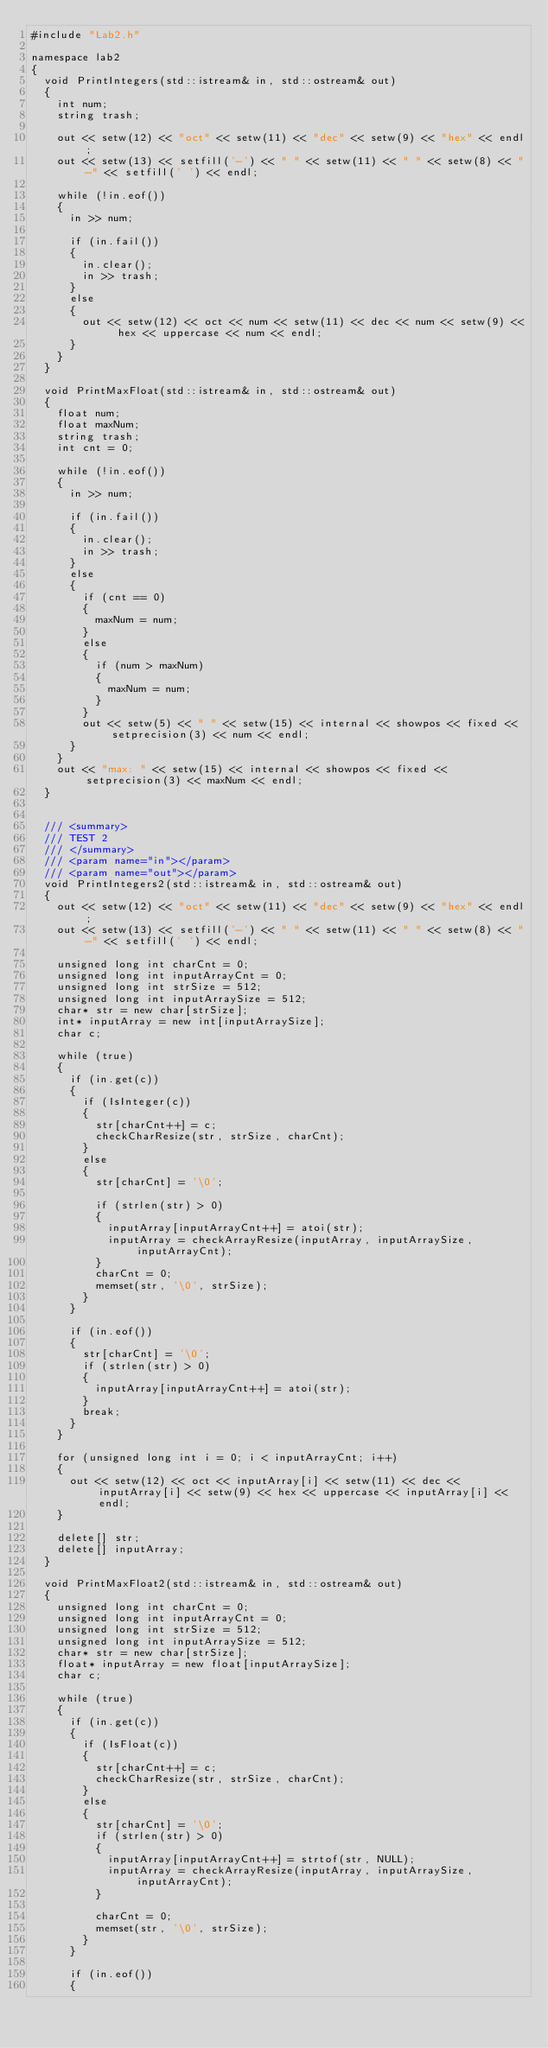Convert code to text. <code><loc_0><loc_0><loc_500><loc_500><_C++_>#include "Lab2.h"

namespace lab2
{
	void PrintIntegers(std::istream& in, std::ostream& out)
	{
		int num;
		string trash;

		out << setw(12) << "oct" << setw(11) << "dec" << setw(9) << "hex" << endl;
		out << setw(13) << setfill('-') << " " << setw(11) << " " << setw(8) << "-" << setfill(' ') << endl;

		while (!in.eof())
		{
			in >> num;

			if (in.fail())
			{
				in.clear();
				in >> trash;
			}
			else
			{
				out << setw(12) << oct << num << setw(11) << dec << num << setw(9) << hex << uppercase << num << endl;
			}
		}
	}

	void PrintMaxFloat(std::istream& in, std::ostream& out)
	{
		float num;
		float maxNum;
		string trash;
		int cnt = 0;

		while (!in.eof())
		{
			in >> num;

			if (in.fail())
			{
				in.clear();
				in >> trash;
			}
			else
			{
				if (cnt == 0)
				{
					maxNum = num;
				}
				else
				{
					if (num > maxNum)
					{
						maxNum = num;
					}
				}
				out << setw(5) << " " << setw(15) << internal << showpos << fixed << setprecision(3) << num << endl;
			}
		}
		out << "max: " << setw(15) << internal << showpos << fixed << setprecision(3) << maxNum << endl;
	}


	/// <summary>
	/// TEST 2
	/// </summary>
	/// <param name="in"></param>
	/// <param name="out"></param>
	void PrintIntegers2(std::istream& in, std::ostream& out)
	{
		out << setw(12) << "oct" << setw(11) << "dec" << setw(9) << "hex" << endl;
		out << setw(13) << setfill('-') << " " << setw(11) << " " << setw(8) << "-" << setfill(' ') << endl;

		unsigned long int charCnt = 0;
		unsigned long int inputArrayCnt = 0;
		unsigned long int strSize = 512;
		unsigned long int inputArraySize = 512;
		char* str = new char[strSize];
		int* inputArray = new int[inputArraySize];
		char c;

		while (true)
		{
			if (in.get(c))
			{
				if (IsInteger(c))
				{
					str[charCnt++] = c;
					checkCharResize(str, strSize, charCnt);
				}
				else
				{
					str[charCnt] = '\0';

					if (strlen(str) > 0)
					{
						inputArray[inputArrayCnt++] = atoi(str);
						inputArray = checkArrayResize(inputArray, inputArraySize, inputArrayCnt);
					}
					charCnt = 0;
					memset(str, '\0', strSize);
				}
			}

			if (in.eof())
			{
				str[charCnt] = '\0';
				if (strlen(str) > 0)
				{
					inputArray[inputArrayCnt++] = atoi(str);
				}
				break;
			}
		}

		for (unsigned long int i = 0; i < inputArrayCnt; i++)
		{
			out << setw(12) << oct << inputArray[i] << setw(11) << dec << inputArray[i] << setw(9) << hex << uppercase << inputArray[i] << endl;
		}

		delete[] str;
		delete[] inputArray;
	}

	void PrintMaxFloat2(std::istream& in, std::ostream& out)
	{
		unsigned long int charCnt = 0;
		unsigned long int inputArrayCnt = 0;
		unsigned long int strSize = 512;
		unsigned long int inputArraySize = 512;
		char* str = new char[strSize];
		float* inputArray = new float[inputArraySize];
		char c;

		while (true)
		{
			if (in.get(c))
			{
				if (IsFloat(c))
				{
					str[charCnt++] = c;
					checkCharResize(str, strSize, charCnt);
				}
				else
				{
					str[charCnt] = '\0';
					if (strlen(str) > 0)
					{
						inputArray[inputArrayCnt++] = strtof(str, NULL);
						inputArray = checkArrayResize(inputArray, inputArraySize, inputArrayCnt);
					}

					charCnt = 0;
					memset(str, '\0', strSize);
				}
			}

			if (in.eof())
			{</code> 